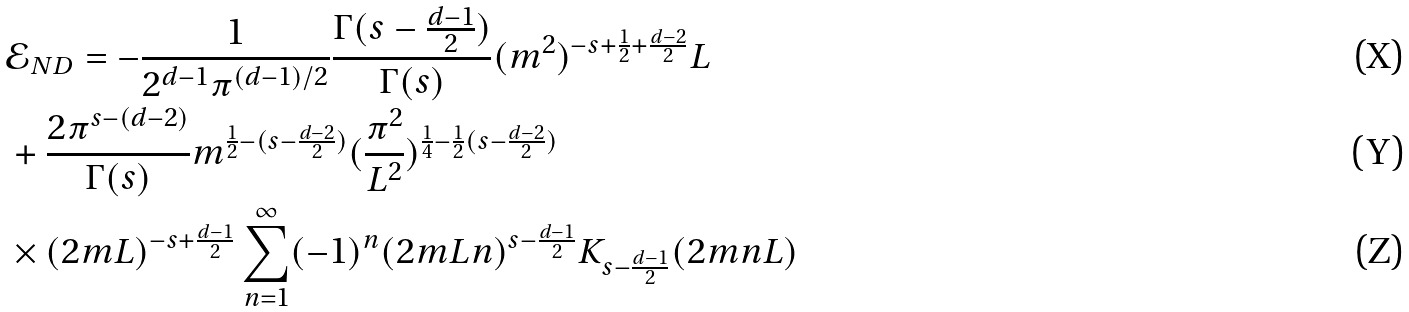<formula> <loc_0><loc_0><loc_500><loc_500>& \mathcal { E } _ { N D } = - \frac { 1 } { 2 ^ { d - 1 } \pi ^ { ( d - 1 ) / 2 } } \frac { \Gamma ( s - \frac { d - 1 } { 2 } ) } { \Gamma ( s ) } ( m ^ { 2 } ) ^ { - s + \frac { 1 } { 2 } + \frac { d - 2 } { 2 } } L \\ & + \frac { 2 \pi ^ { s - ( d - 2 ) } } { \Gamma ( s ) } m ^ { \frac { 1 } { 2 } - ( s - \frac { d - 2 } { 2 } ) } ( \frac { \pi ^ { 2 } } { L ^ { 2 } } ) ^ { \frac { 1 } { 4 } - \frac { 1 } { 2 } ( s - \frac { d - 2 } { 2 } ) } \\ & \times ( 2 m L ) ^ { - s + \frac { d - 1 } { 2 } } \sum _ { n = 1 } ^ { \infty } ( - 1 ) ^ { n } ( 2 m L n ) ^ { s - \frac { d - 1 } { 2 } } K _ { s - \frac { d - 1 } { 2 } } ( 2 m n L )</formula> 